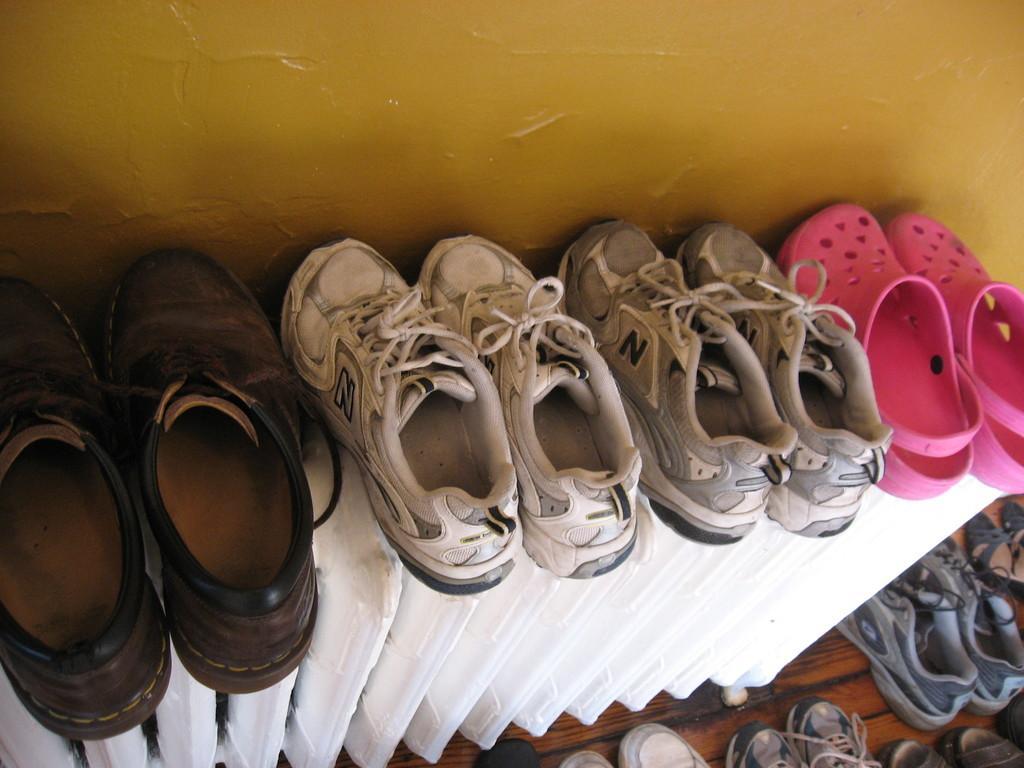In one or two sentences, can you explain what this image depicts? In the middle of this image, there are shoes in different colors arranged on a shelf. At the bottom of this image, there are other shoes and slippers arranged on the floor. In the background, there is a wall. 